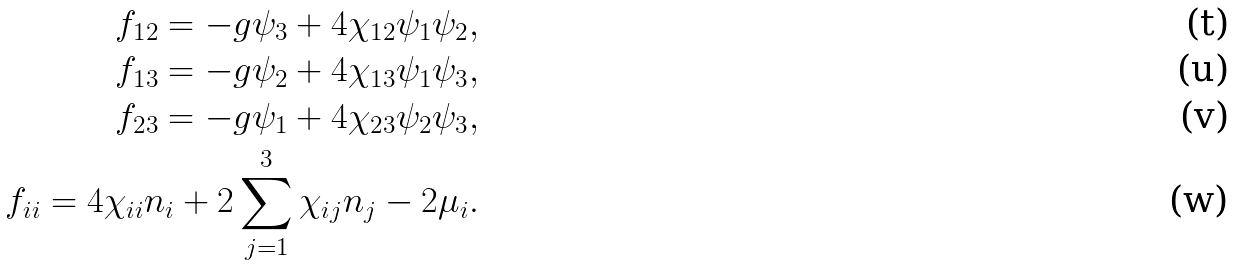Convert formula to latex. <formula><loc_0><loc_0><loc_500><loc_500>f _ { 1 2 } = - g \psi _ { 3 } + 4 \chi _ { 1 2 } \psi _ { 1 } \psi _ { 2 } , \\ f _ { 1 3 } = - g \psi _ { 2 } + 4 \chi _ { 1 3 } \psi _ { 1 } \psi _ { 3 } , \\ f _ { 2 3 } = - g \psi _ { 1 } + 4 \chi _ { 2 3 } \psi _ { 2 } \psi _ { 3 } , \\ f _ { i i } = 4 \chi _ { i i } n _ { i } + 2 \sum _ { j = 1 } ^ { 3 } \chi _ { i j } n _ { j } - 2 \mu _ { i } .</formula> 